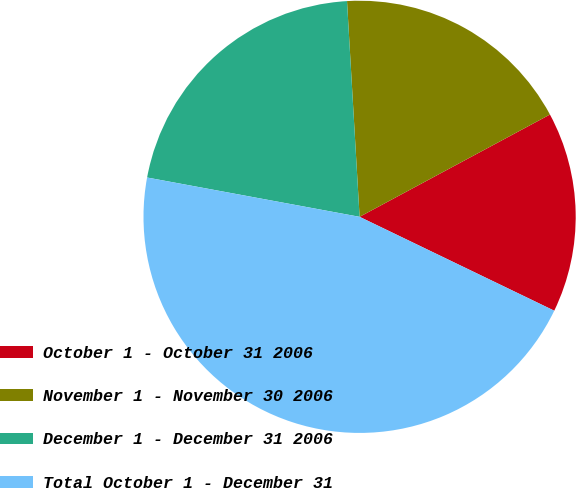Convert chart to OTSL. <chart><loc_0><loc_0><loc_500><loc_500><pie_chart><fcel>October 1 - October 31 2006<fcel>November 1 - November 30 2006<fcel>December 1 - December 31 2006<fcel>Total October 1 - December 31<nl><fcel>15.0%<fcel>18.08%<fcel>21.16%<fcel>45.76%<nl></chart> 